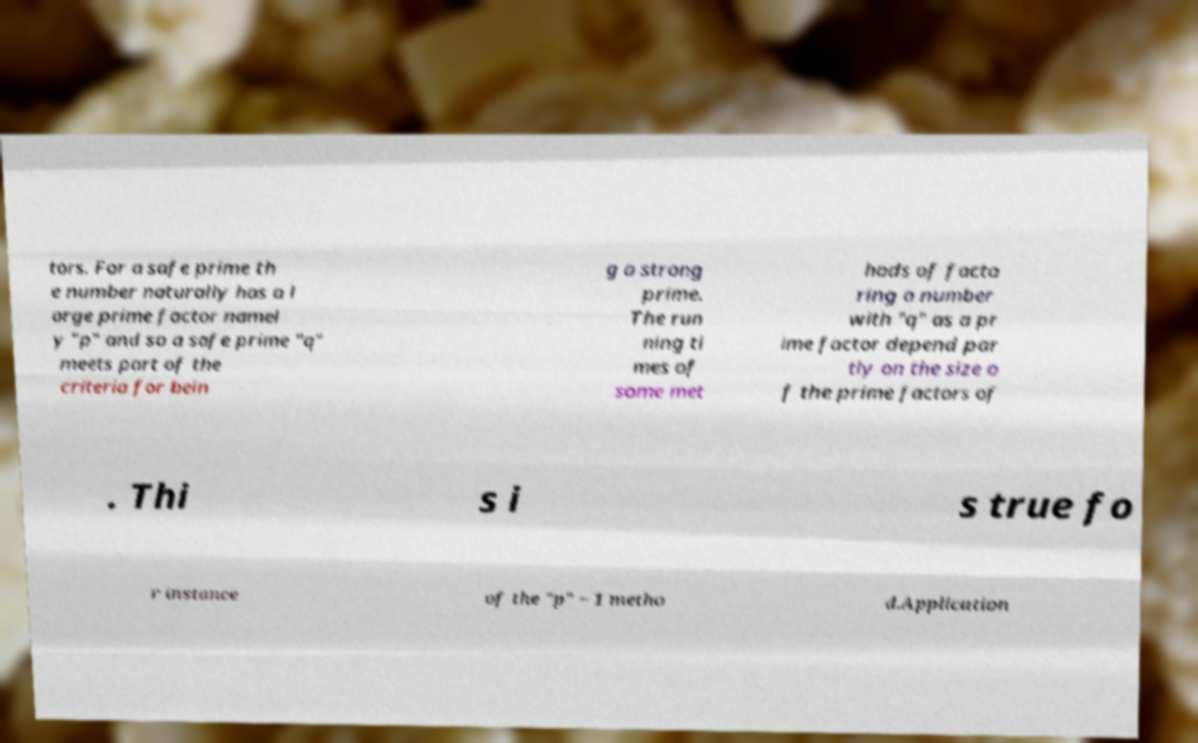Can you read and provide the text displayed in the image?This photo seems to have some interesting text. Can you extract and type it out for me? tors. For a safe prime th e number naturally has a l arge prime factor namel y "p" and so a safe prime "q" meets part of the criteria for bein g a strong prime. The run ning ti mes of some met hods of facto ring a number with "q" as a pr ime factor depend par tly on the size o f the prime factors of . Thi s i s true fo r instance of the "p" − 1 metho d.Application 